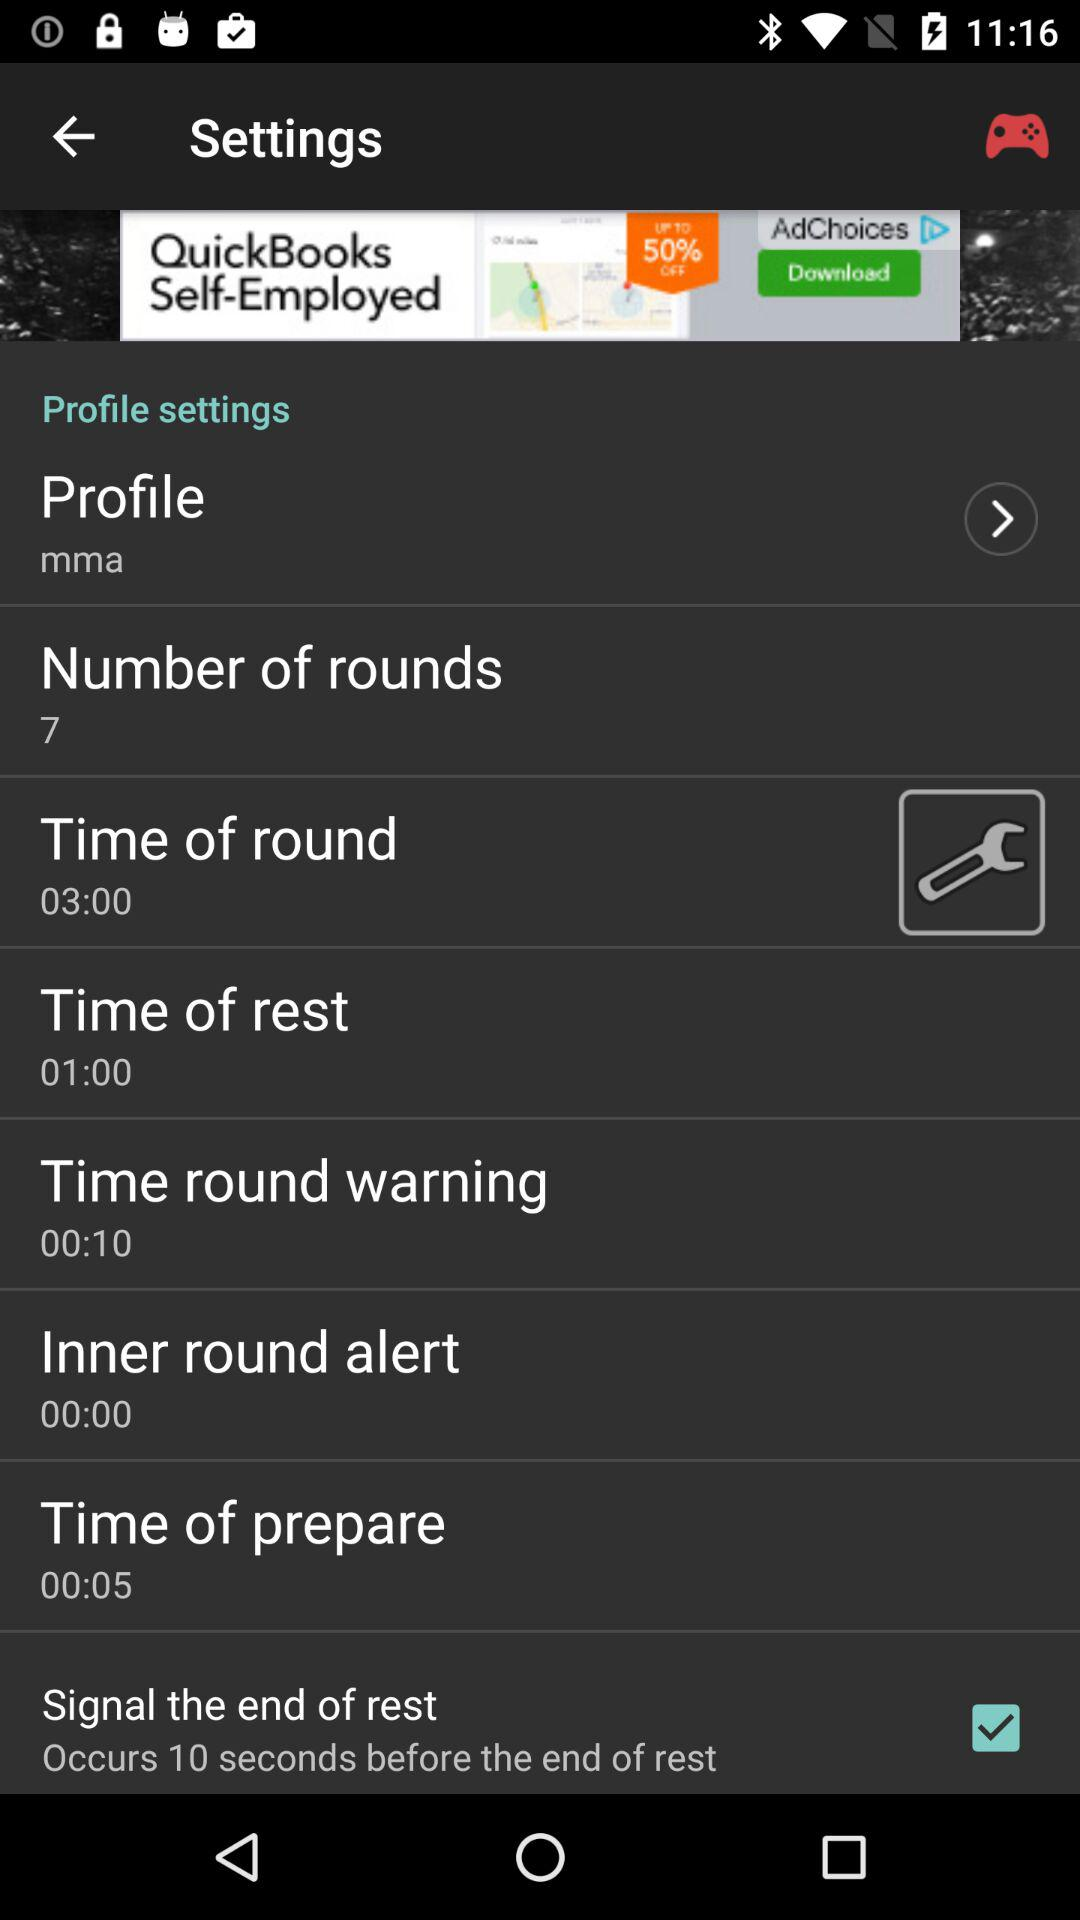What is the time of round? The time of round is 03:00. 